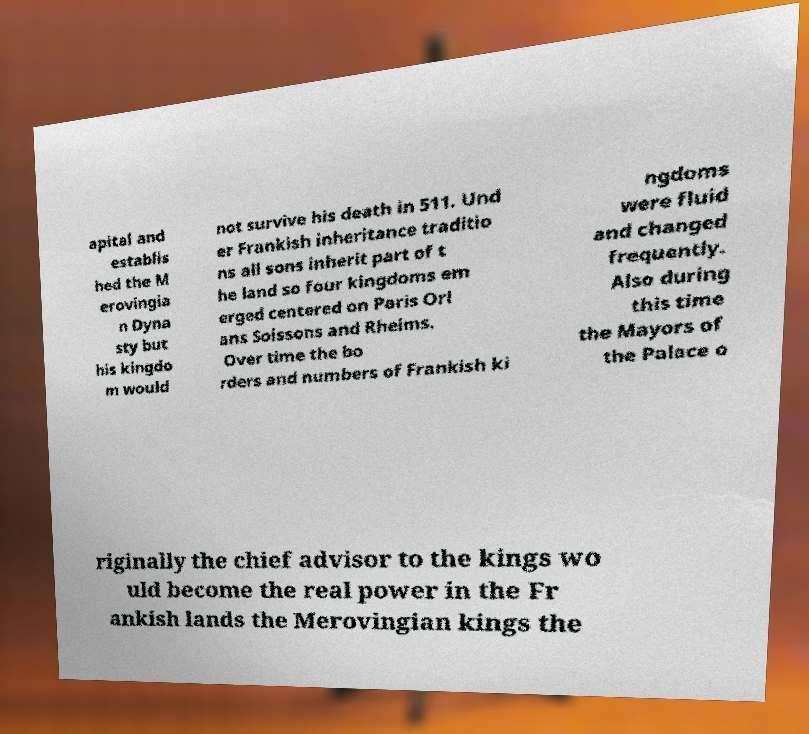What messages or text are displayed in this image? I need them in a readable, typed format. apital and establis hed the M erovingia n Dyna sty but his kingdo m would not survive his death in 511. Und er Frankish inheritance traditio ns all sons inherit part of t he land so four kingdoms em erged centered on Paris Orl ans Soissons and Rheims. Over time the bo rders and numbers of Frankish ki ngdoms were fluid and changed frequently. Also during this time the Mayors of the Palace o riginally the chief advisor to the kings wo uld become the real power in the Fr ankish lands the Merovingian kings the 